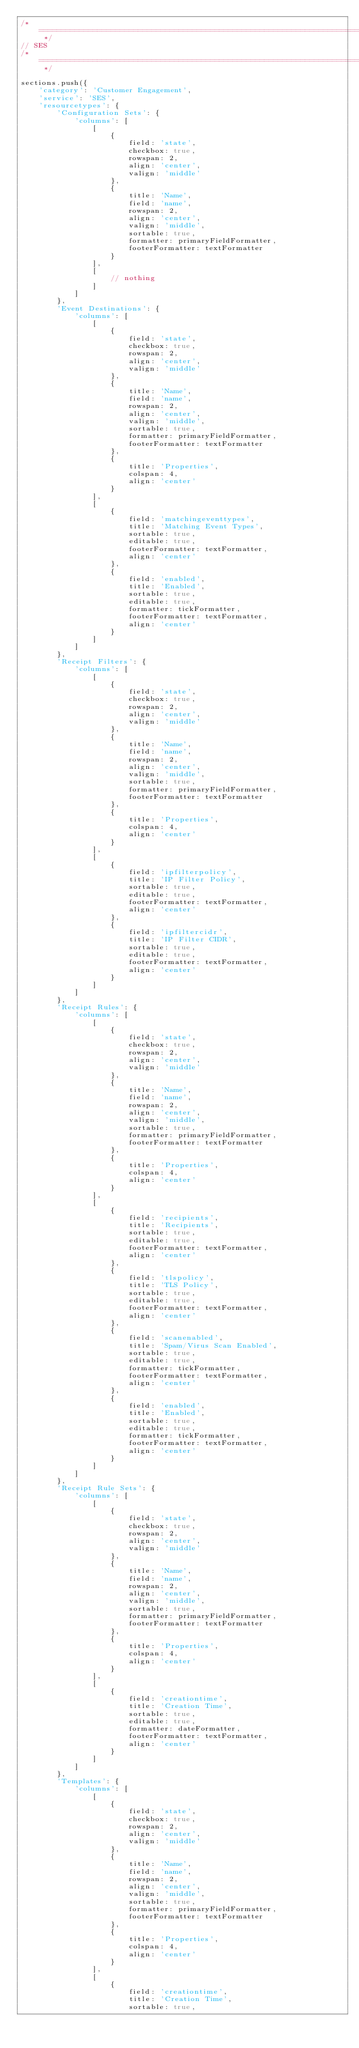Convert code to text. <code><loc_0><loc_0><loc_500><loc_500><_JavaScript_>/* ========================================================================== */
// SES
/* ========================================================================== */

sections.push({
    'category': 'Customer Engagement',
    'service': 'SES',
    'resourcetypes': {
        'Configuration Sets': {
            'columns': [
                [
                    {
                        field: 'state',
                        checkbox: true,
                        rowspan: 2,
                        align: 'center',
                        valign: 'middle'
                    },
                    {
                        title: 'Name',
                        field: 'name',
                        rowspan: 2,
                        align: 'center',
                        valign: 'middle',
                        sortable: true,
                        formatter: primaryFieldFormatter,
                        footerFormatter: textFormatter
                    }
                ],
                [
                    // nothing
                ]
            ]
        },
        'Event Destinations': {
            'columns': [
                [
                    {
                        field: 'state',
                        checkbox: true,
                        rowspan: 2,
                        align: 'center',
                        valign: 'middle'
                    },
                    {
                        title: 'Name',
                        field: 'name',
                        rowspan: 2,
                        align: 'center',
                        valign: 'middle',
                        sortable: true,
                        formatter: primaryFieldFormatter,
                        footerFormatter: textFormatter
                    },
                    {
                        title: 'Properties',
                        colspan: 4,
                        align: 'center'
                    }
                ],
                [
                    {
                        field: 'matchingeventtypes',
                        title: 'Matching Event Types',
                        sortable: true,
                        editable: true,
                        footerFormatter: textFormatter,
                        align: 'center'
                    },
                    {
                        field: 'enabled',
                        title: 'Enabled',
                        sortable: true,
                        editable: true,
                        formatter: tickFormatter,
                        footerFormatter: textFormatter,
                        align: 'center'
                    }
                ]
            ]
        },
        'Receipt Filters': {
            'columns': [
                [
                    {
                        field: 'state',
                        checkbox: true,
                        rowspan: 2,
                        align: 'center',
                        valign: 'middle'
                    },
                    {
                        title: 'Name',
                        field: 'name',
                        rowspan: 2,
                        align: 'center',
                        valign: 'middle',
                        sortable: true,
                        formatter: primaryFieldFormatter,
                        footerFormatter: textFormatter
                    },
                    {
                        title: 'Properties',
                        colspan: 4,
                        align: 'center'
                    }
                ],
                [
                    {
                        field: 'ipfilterpolicy',
                        title: 'IP Filter Policy',
                        sortable: true,
                        editable: true,
                        footerFormatter: textFormatter,
                        align: 'center'
                    },
                    {
                        field: 'ipfiltercidr',
                        title: 'IP Filter CIDR',
                        sortable: true,
                        editable: true,
                        footerFormatter: textFormatter,
                        align: 'center'
                    }
                ]
            ]
        },
        'Receipt Rules': {
            'columns': [
                [
                    {
                        field: 'state',
                        checkbox: true,
                        rowspan: 2,
                        align: 'center',
                        valign: 'middle'
                    },
                    {
                        title: 'Name',
                        field: 'name',
                        rowspan: 2,
                        align: 'center',
                        valign: 'middle',
                        sortable: true,
                        formatter: primaryFieldFormatter,
                        footerFormatter: textFormatter
                    },
                    {
                        title: 'Properties',
                        colspan: 4,
                        align: 'center'
                    }
                ],
                [
                    {
                        field: 'recipients',
                        title: 'Recipients',
                        sortable: true,
                        editable: true,
                        footerFormatter: textFormatter,
                        align: 'center'
                    },
                    {
                        field: 'tlspolicy',
                        title: 'TLS Policy',
                        sortable: true,
                        editable: true,
                        footerFormatter: textFormatter,
                        align: 'center'
                    },
                    {
                        field: 'scanenabled',
                        title: 'Spam/Virus Scan Enabled',
                        sortable: true,
                        editable: true,
                        formatter: tickFormatter,
                        footerFormatter: textFormatter,
                        align: 'center'
                    },
                    {
                        field: 'enabled',
                        title: 'Enabled',
                        sortable: true,
                        editable: true,
                        formatter: tickFormatter,
                        footerFormatter: textFormatter,
                        align: 'center'
                    }
                ]
            ]
        },
        'Receipt Rule Sets': {
            'columns': [
                [
                    {
                        field: 'state',
                        checkbox: true,
                        rowspan: 2,
                        align: 'center',
                        valign: 'middle'
                    },
                    {
                        title: 'Name',
                        field: 'name',
                        rowspan: 2,
                        align: 'center',
                        valign: 'middle',
                        sortable: true,
                        formatter: primaryFieldFormatter,
                        footerFormatter: textFormatter
                    },
                    {
                        title: 'Properties',
                        colspan: 4,
                        align: 'center'
                    }
                ],
                [
                    {
                        field: 'creationtime',
                        title: 'Creation Time',
                        sortable: true,
                        editable: true,
                        formatter: dateFormatter,
                        footerFormatter: textFormatter,
                        align: 'center'
                    }
                ]
            ]
        },
        'Templates': {
            'columns': [
                [
                    {
                        field: 'state',
                        checkbox: true,
                        rowspan: 2,
                        align: 'center',
                        valign: 'middle'
                    },
                    {
                        title: 'Name',
                        field: 'name',
                        rowspan: 2,
                        align: 'center',
                        valign: 'middle',
                        sortable: true,
                        formatter: primaryFieldFormatter,
                        footerFormatter: textFormatter
                    },
                    {
                        title: 'Properties',
                        colspan: 4,
                        align: 'center'
                    }
                ],
                [
                    {
                        field: 'creationtime',
                        title: 'Creation Time',
                        sortable: true,</code> 